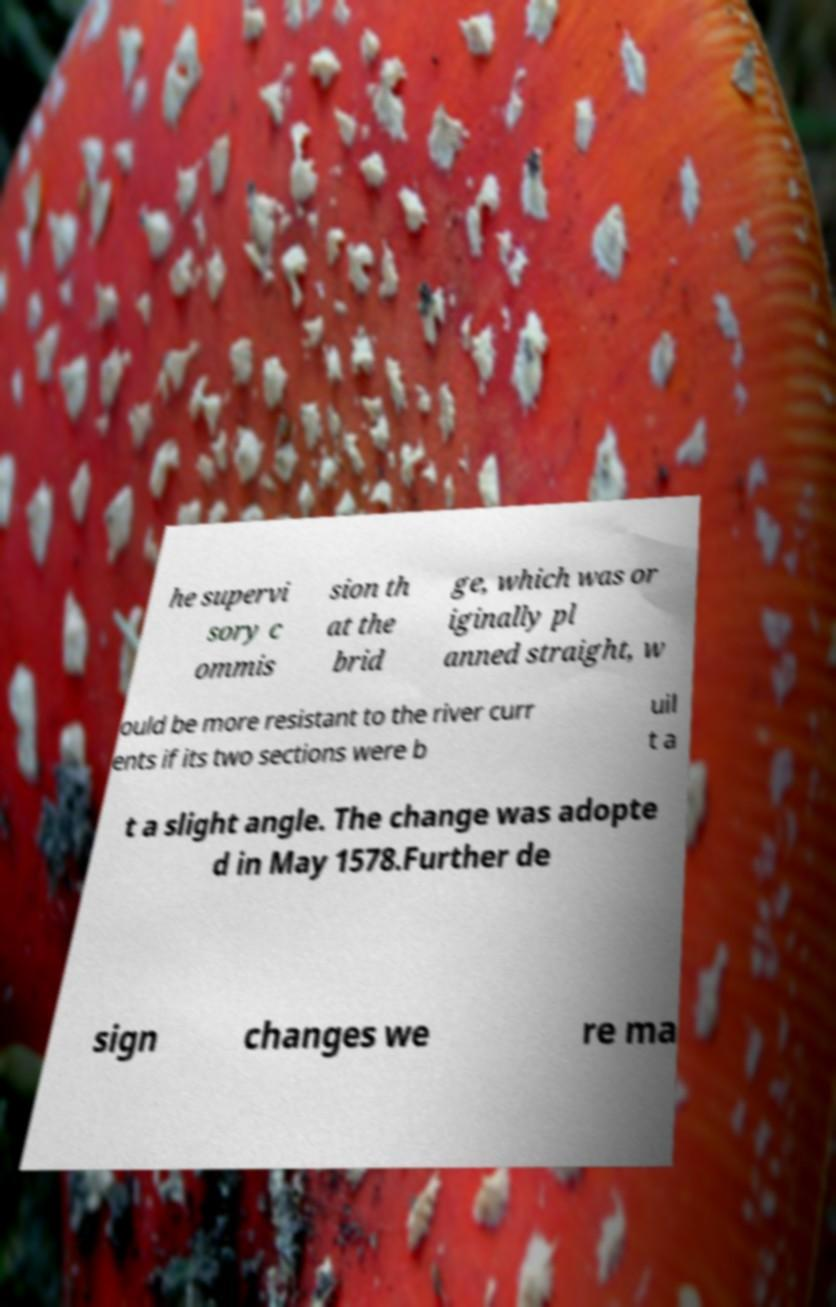There's text embedded in this image that I need extracted. Can you transcribe it verbatim? he supervi sory c ommis sion th at the brid ge, which was or iginally pl anned straight, w ould be more resistant to the river curr ents if its two sections were b uil t a t a slight angle. The change was adopte d in May 1578.Further de sign changes we re ma 